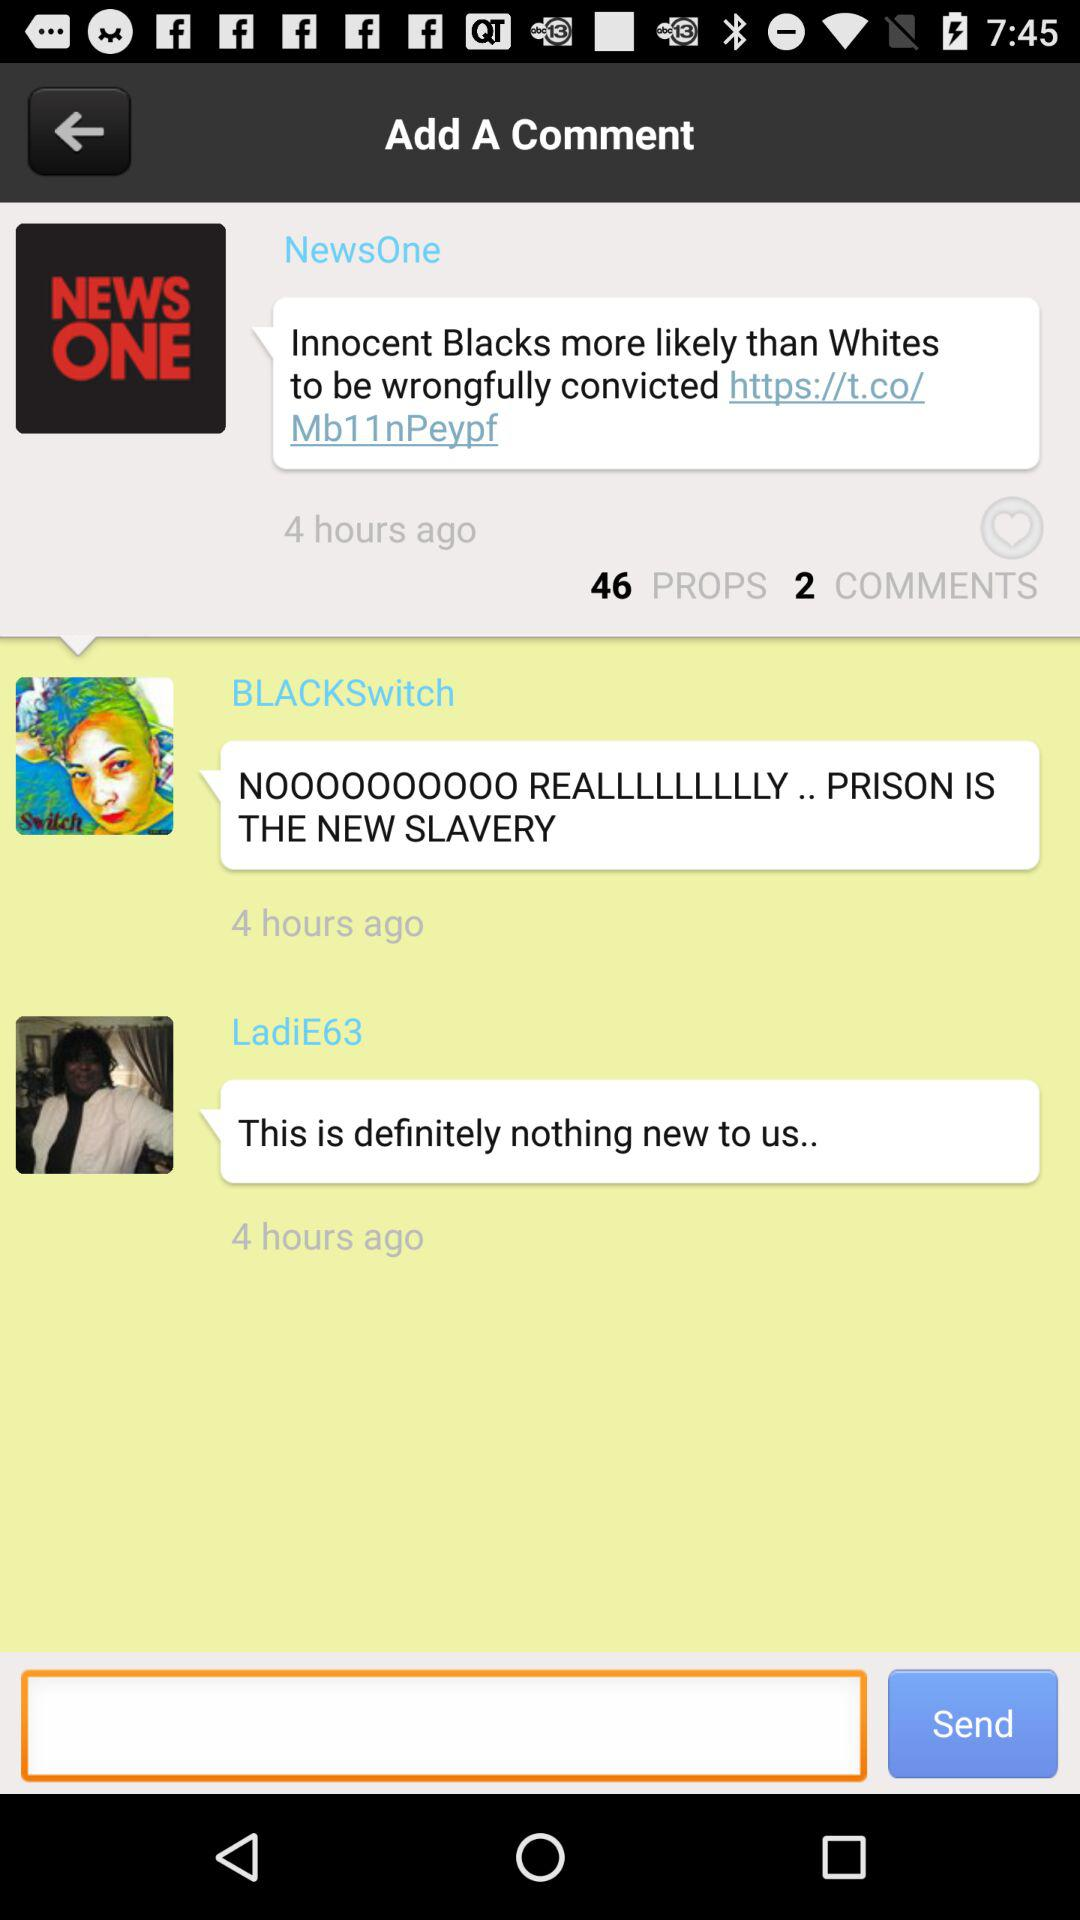How many comments have been made on the article?
Answer the question using a single word or phrase. 2 